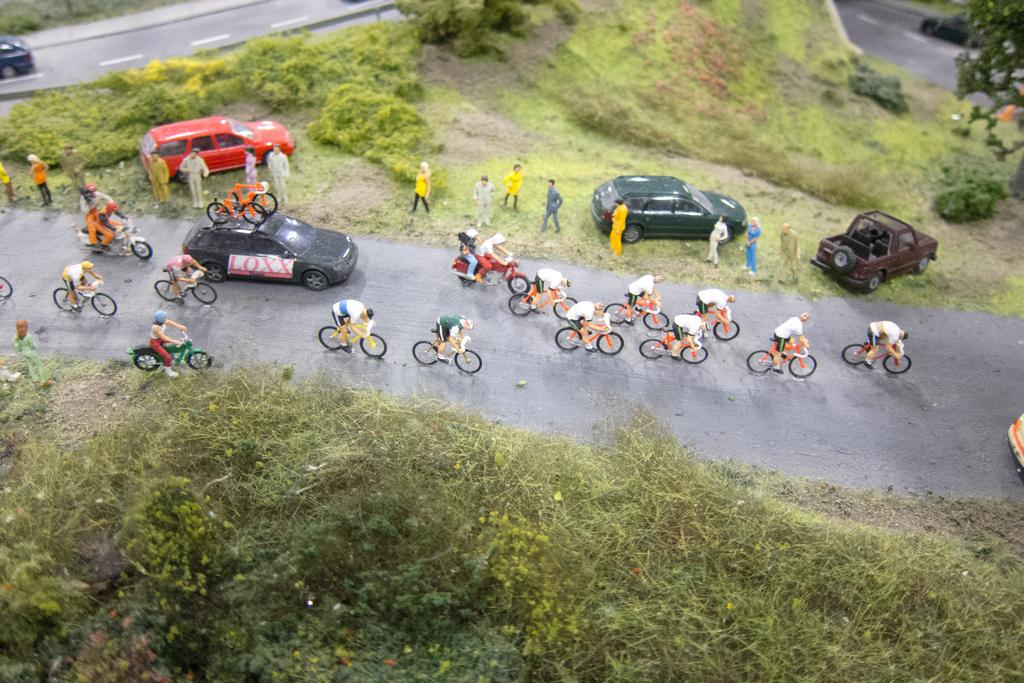What type of vehicles are present in the image? There are bicycles and cars in the image. Who is operating the bicycles in the image? There are people riding the bicycles in the image. What type of vegetation can be seen in the image? There are plants and grass in the image. What is the price of the hand in the image? There is no hand present in the image, so it is not possible to determine its price. 